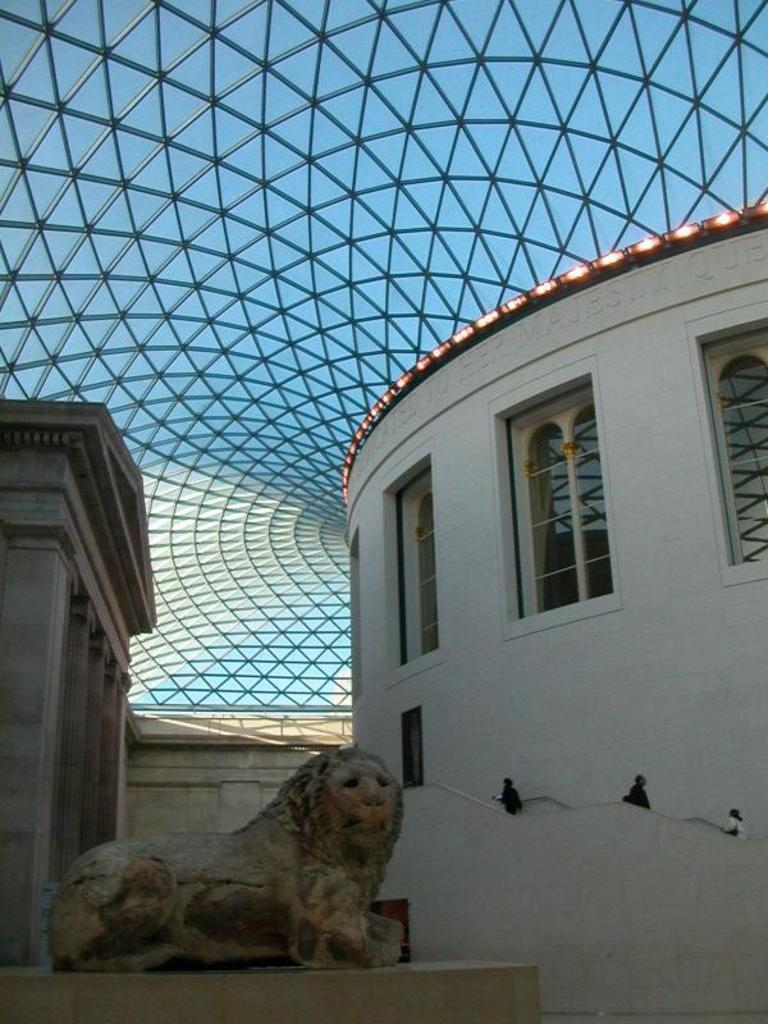What type of statue is present in the image? There is a lion statue in the image. What structure can be seen in the background? There is a building in the image. What are the people in the image doing? People are standing on the building. What type of roof is visible on the building? There is a glass roof in the image. What type of engine is powering the lion statue in the image? There is no engine present in the image, as the lion statue is not a functioning vehicle. What type of polish is being used to maintain the glass roof in the image? There is no information about polish or maintenance in the image, so we cannot determine what type of polish is being used. 